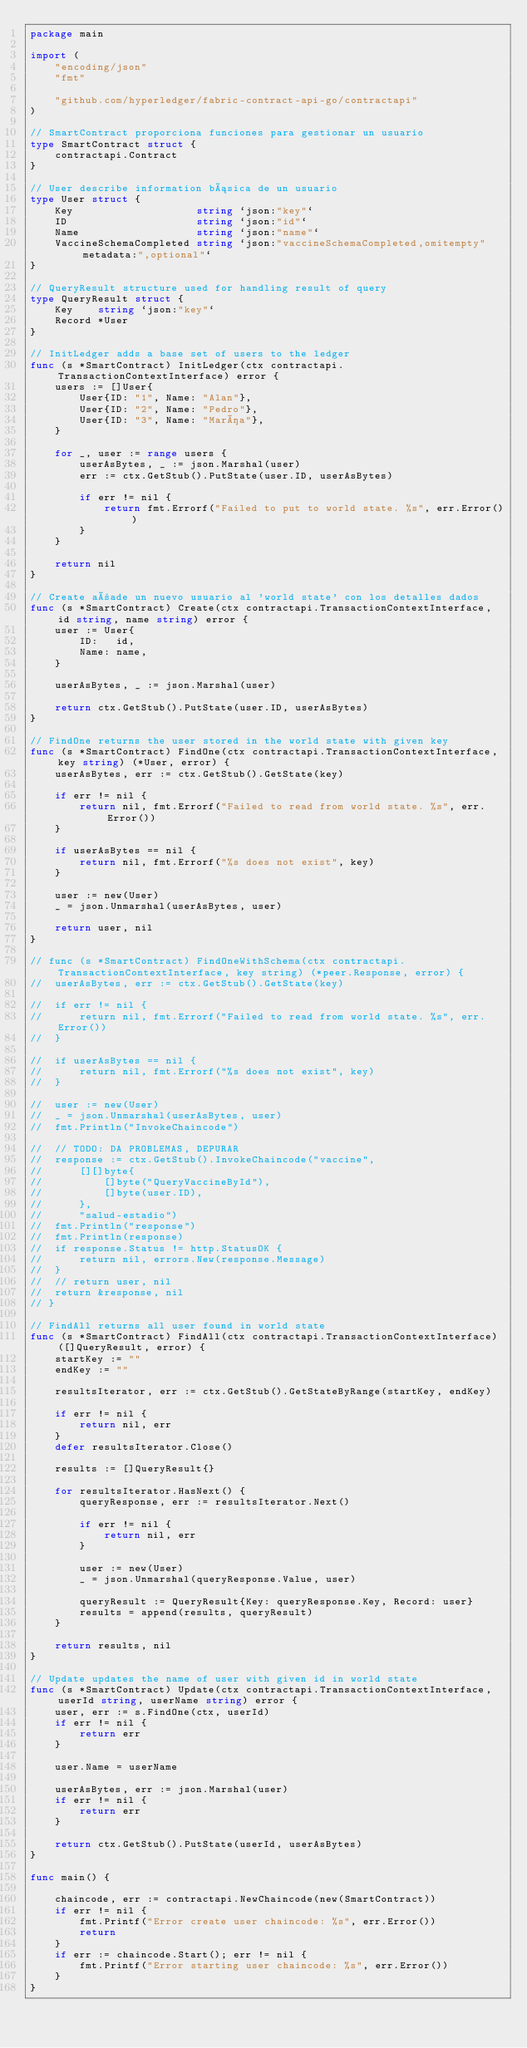Convert code to text. <code><loc_0><loc_0><loc_500><loc_500><_Go_>package main

import (
	"encoding/json"
	"fmt"

	"github.com/hyperledger/fabric-contract-api-go/contractapi"
)

// SmartContract proporciona funciones para gestionar un usuario
type SmartContract struct {
	contractapi.Contract
}

// User describe information básica de un usuario
type User struct {
	Key                    string `json:"key"`
	ID                     string `json:"id"`
	Name                   string `json:"name"`
	VaccineSchemaCompleted string `json:"vaccineSchemaCompleted,omitempty" metadata:",optional"`
}

// QueryResult structure used for handling result of query
type QueryResult struct {
	Key    string `json:"key"`
	Record *User
}

// InitLedger adds a base set of users to the ledger
func (s *SmartContract) InitLedger(ctx contractapi.TransactionContextInterface) error {
	users := []User{
		User{ID: "1", Name: "Alan"},
		User{ID: "2", Name: "Pedro"},
		User{ID: "3", Name: "María"},
	}

	for _, user := range users {
		userAsBytes, _ := json.Marshal(user)
		err := ctx.GetStub().PutState(user.ID, userAsBytes)

		if err != nil {
			return fmt.Errorf("Failed to put to world state. %s", err.Error())
		}
	}

	return nil
}

// Create añade un nuevo usuario al 'world state' con los detalles dados
func (s *SmartContract) Create(ctx contractapi.TransactionContextInterface, id string, name string) error {
	user := User{
		ID:   id,
		Name: name,
	}

	userAsBytes, _ := json.Marshal(user)

	return ctx.GetStub().PutState(user.ID, userAsBytes)
}

// FindOne returns the user stored in the world state with given key
func (s *SmartContract) FindOne(ctx contractapi.TransactionContextInterface, key string) (*User, error) {
	userAsBytes, err := ctx.GetStub().GetState(key)

	if err != nil {
		return nil, fmt.Errorf("Failed to read from world state. %s", err.Error())
	}

	if userAsBytes == nil {
		return nil, fmt.Errorf("%s does not exist", key)
	}

	user := new(User)
	_ = json.Unmarshal(userAsBytes, user)

	return user, nil
}

// func (s *SmartContract) FindOneWithSchema(ctx contractapi.TransactionContextInterface, key string) (*peer.Response, error) {
// 	userAsBytes, err := ctx.GetStub().GetState(key)

// 	if err != nil {
// 		return nil, fmt.Errorf("Failed to read from world state. %s", err.Error())
// 	}

// 	if userAsBytes == nil {
// 		return nil, fmt.Errorf("%s does not exist", key)
// 	}

// 	user := new(User)
// 	_ = json.Unmarshal(userAsBytes, user)
// 	fmt.Println("InvokeChaincode")

// 	// TODO: DA PROBLEMAS, DEPURAR
// 	response := ctx.GetStub().InvokeChaincode("vaccine",
// 		[][]byte{
// 			[]byte("QueryVaccineById"),
// 			[]byte(user.ID),
// 		},
// 		"salud-estadio")
// 	fmt.Println("response")
// 	fmt.Println(response)
// 	if response.Status != http.StatusOK {
// 		return nil, errors.New(response.Message)
// 	}
// 	// return user, nil
// 	return &response, nil
// }

// FindAll returns all user found in world state
func (s *SmartContract) FindAll(ctx contractapi.TransactionContextInterface) ([]QueryResult, error) {
	startKey := ""
	endKey := ""

	resultsIterator, err := ctx.GetStub().GetStateByRange(startKey, endKey)

	if err != nil {
		return nil, err
	}
	defer resultsIterator.Close()

	results := []QueryResult{}

	for resultsIterator.HasNext() {
		queryResponse, err := resultsIterator.Next()

		if err != nil {
			return nil, err
		}

		user := new(User)
		_ = json.Unmarshal(queryResponse.Value, user)

		queryResult := QueryResult{Key: queryResponse.Key, Record: user}
		results = append(results, queryResult)
	}

	return results, nil
}

// Update updates the name of user with given id in world state
func (s *SmartContract) Update(ctx contractapi.TransactionContextInterface, userId string, userName string) error {
	user, err := s.FindOne(ctx, userId)
	if err != nil {
		return err
	}

	user.Name = userName

	userAsBytes, err := json.Marshal(user)
	if err != nil {
		return err
	}

	return ctx.GetStub().PutState(userId, userAsBytes)
}

func main() {

	chaincode, err := contractapi.NewChaincode(new(SmartContract))
	if err != nil {
		fmt.Printf("Error create user chaincode: %s", err.Error())
		return
	}
	if err := chaincode.Start(); err != nil {
		fmt.Printf("Error starting user chaincode: %s", err.Error())
	}
}
</code> 